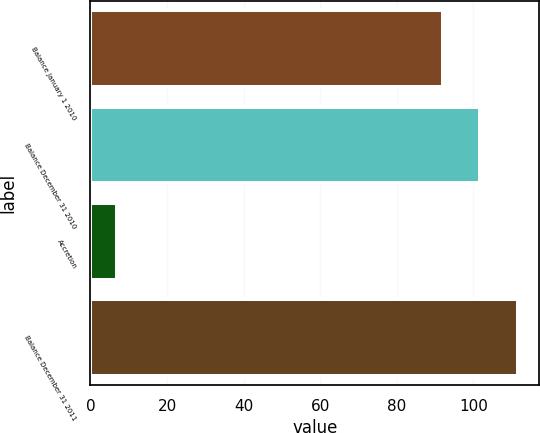<chart> <loc_0><loc_0><loc_500><loc_500><bar_chart><fcel>Balance January 1 2010<fcel>Balance December 31 2010<fcel>Accretion<fcel>Balance December 31 2011<nl><fcel>92<fcel>101.8<fcel>7<fcel>111.6<nl></chart> 